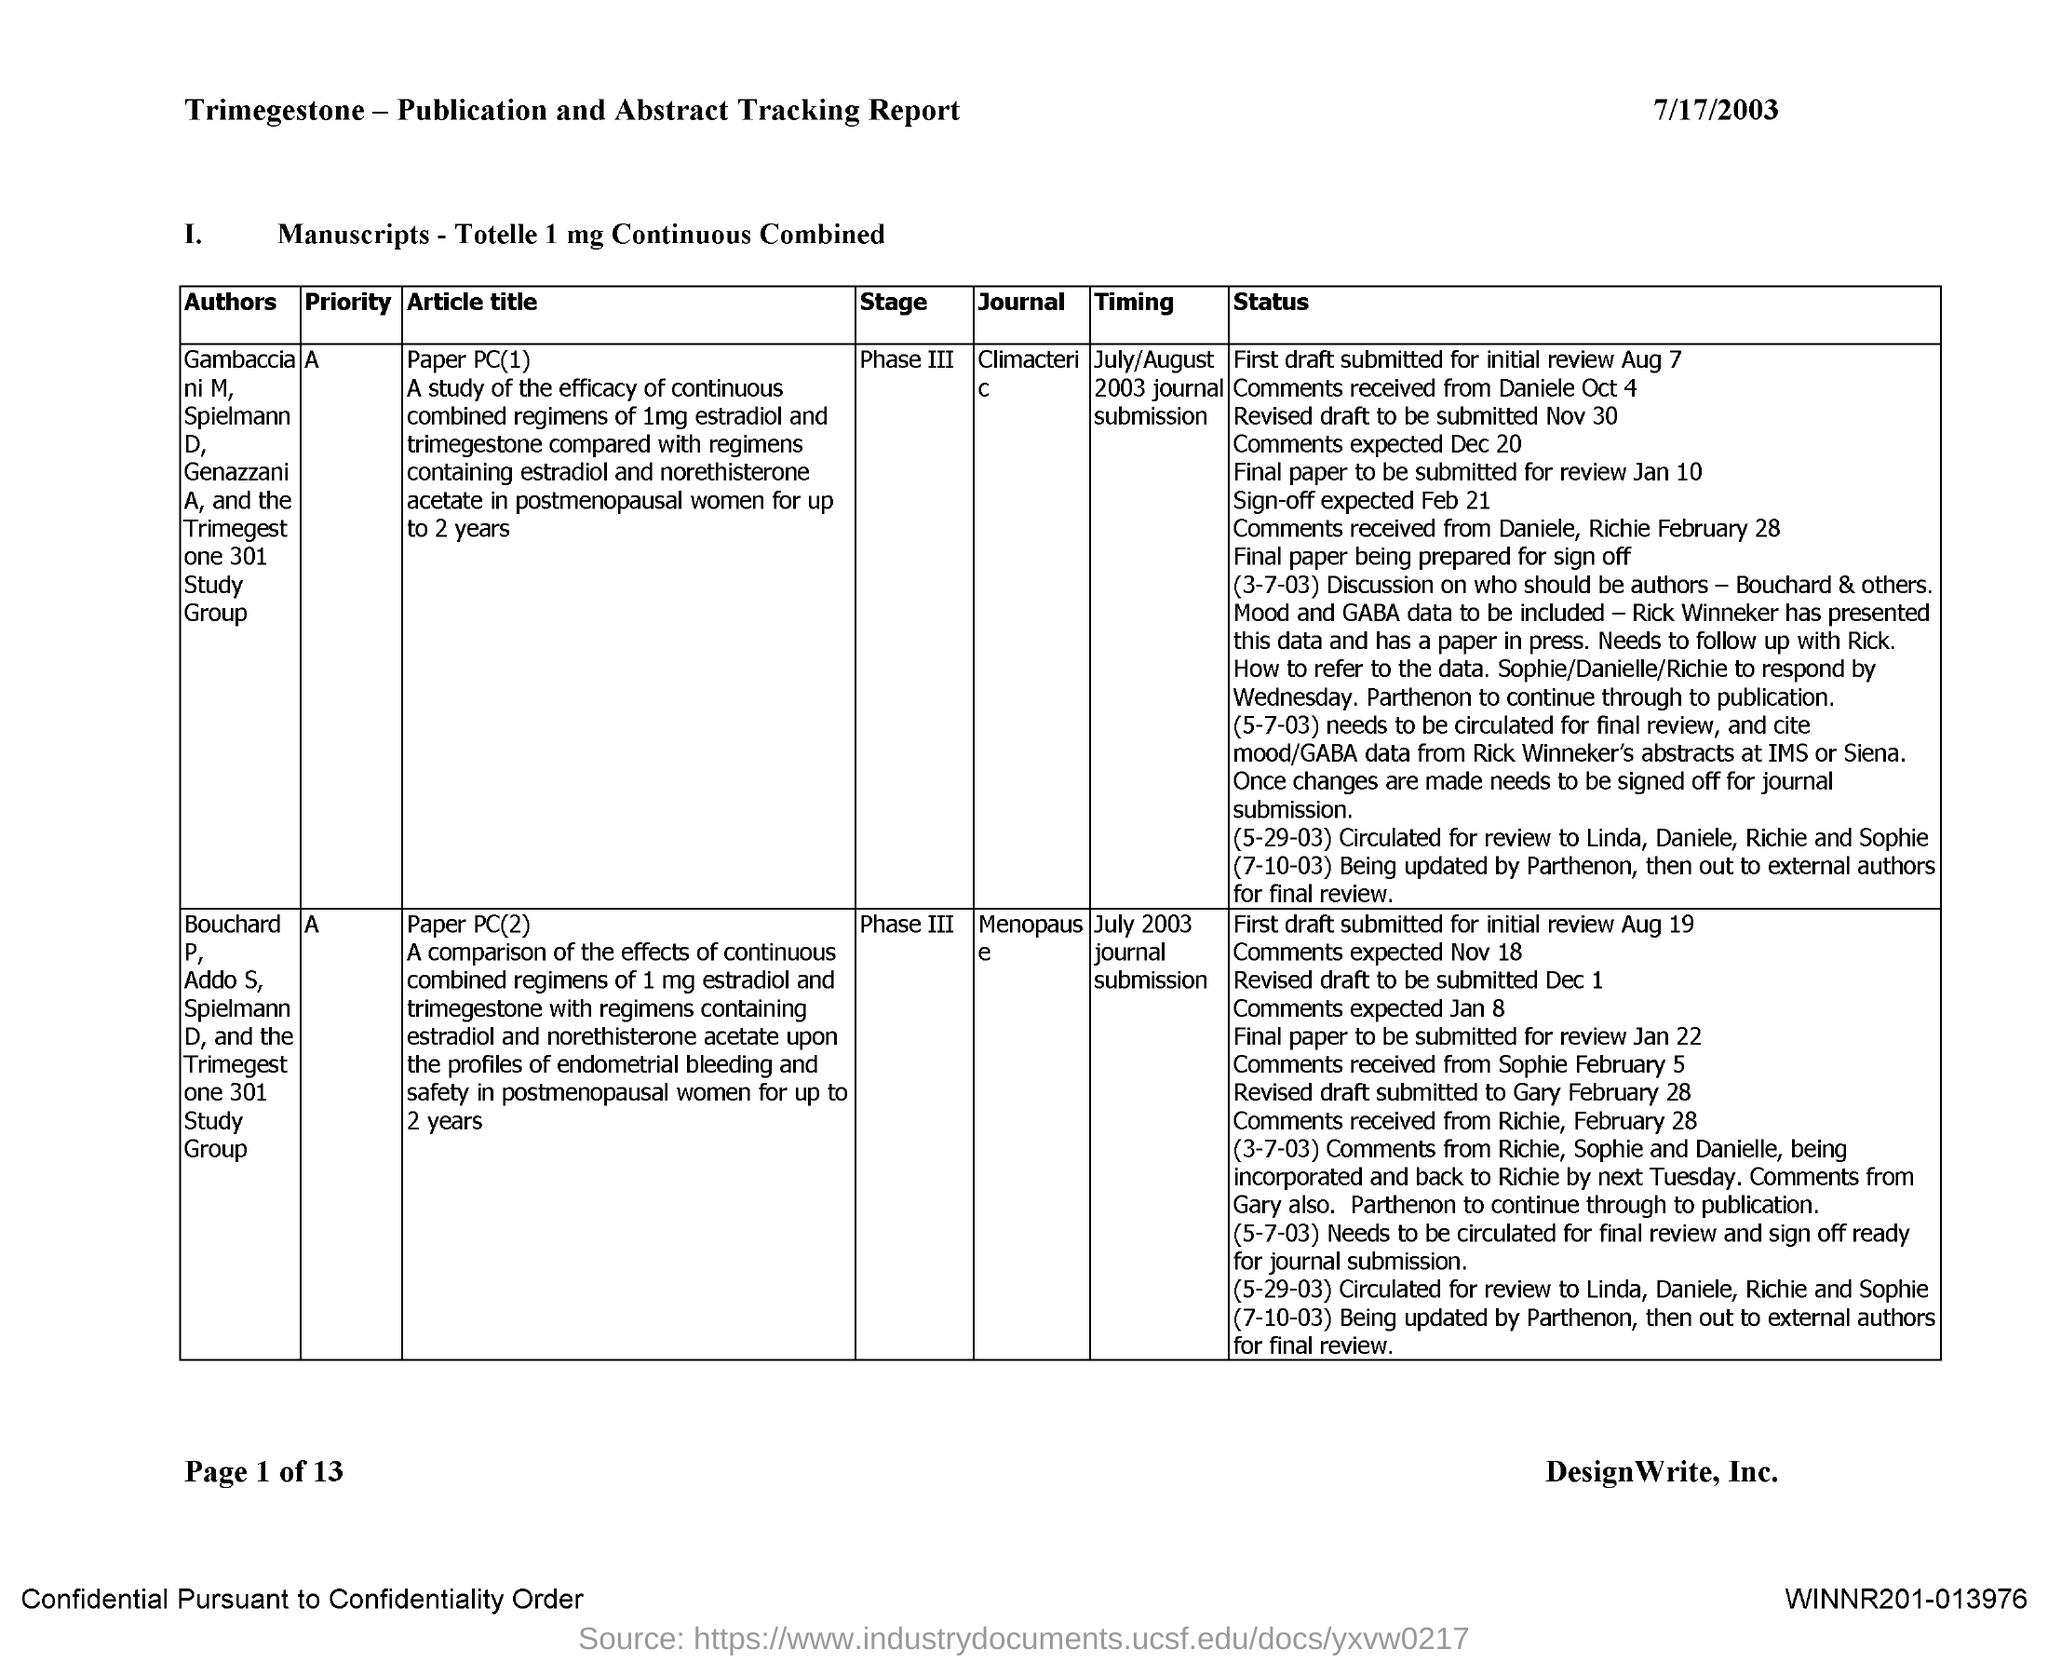Identify some key points in this picture. The article title "Paper PC(1)" is from the journal named "Climacteric. The article title 'paper PC(2)? Menopause..' is published in a journal whose name is not specified. 